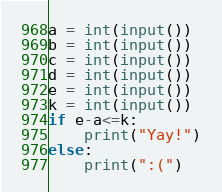<code> <loc_0><loc_0><loc_500><loc_500><_Python_>a = int(input())
b = int(input())
c = int(input())
d = int(input())
e = int(input())
k = int(input())
if e-a<=k:
    print("Yay!")
else:
    print(":(")</code> 